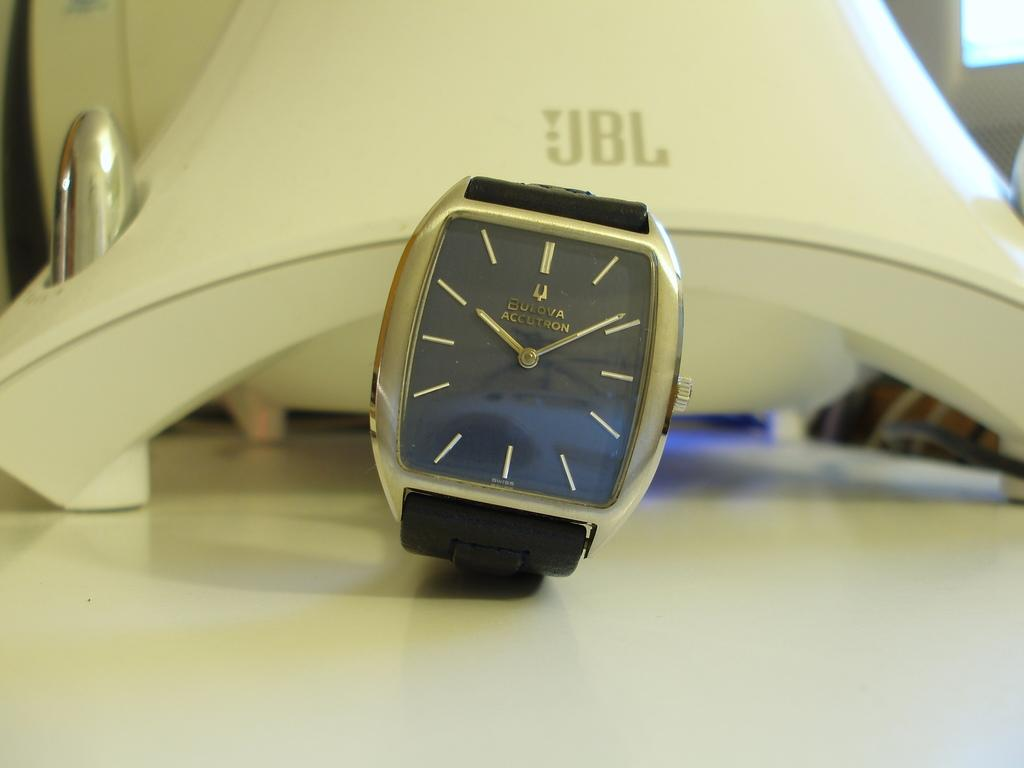<image>
Provide a brief description of the given image. A black and gold watch that says Bukova Accutron on the face. 